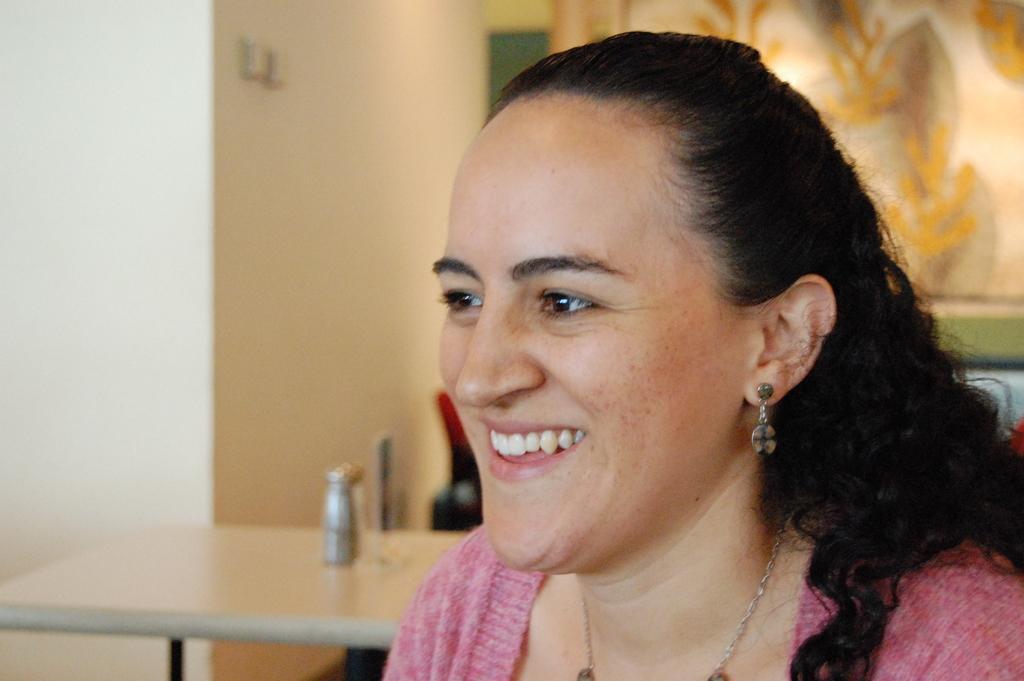Please provide a concise description of this image. This image is taken indoors. In the background there is a wall with a painting on it. On the left side of the image there is a table with a bottle on it. On the right side of the image there is a woman and she is with a smiling face. 